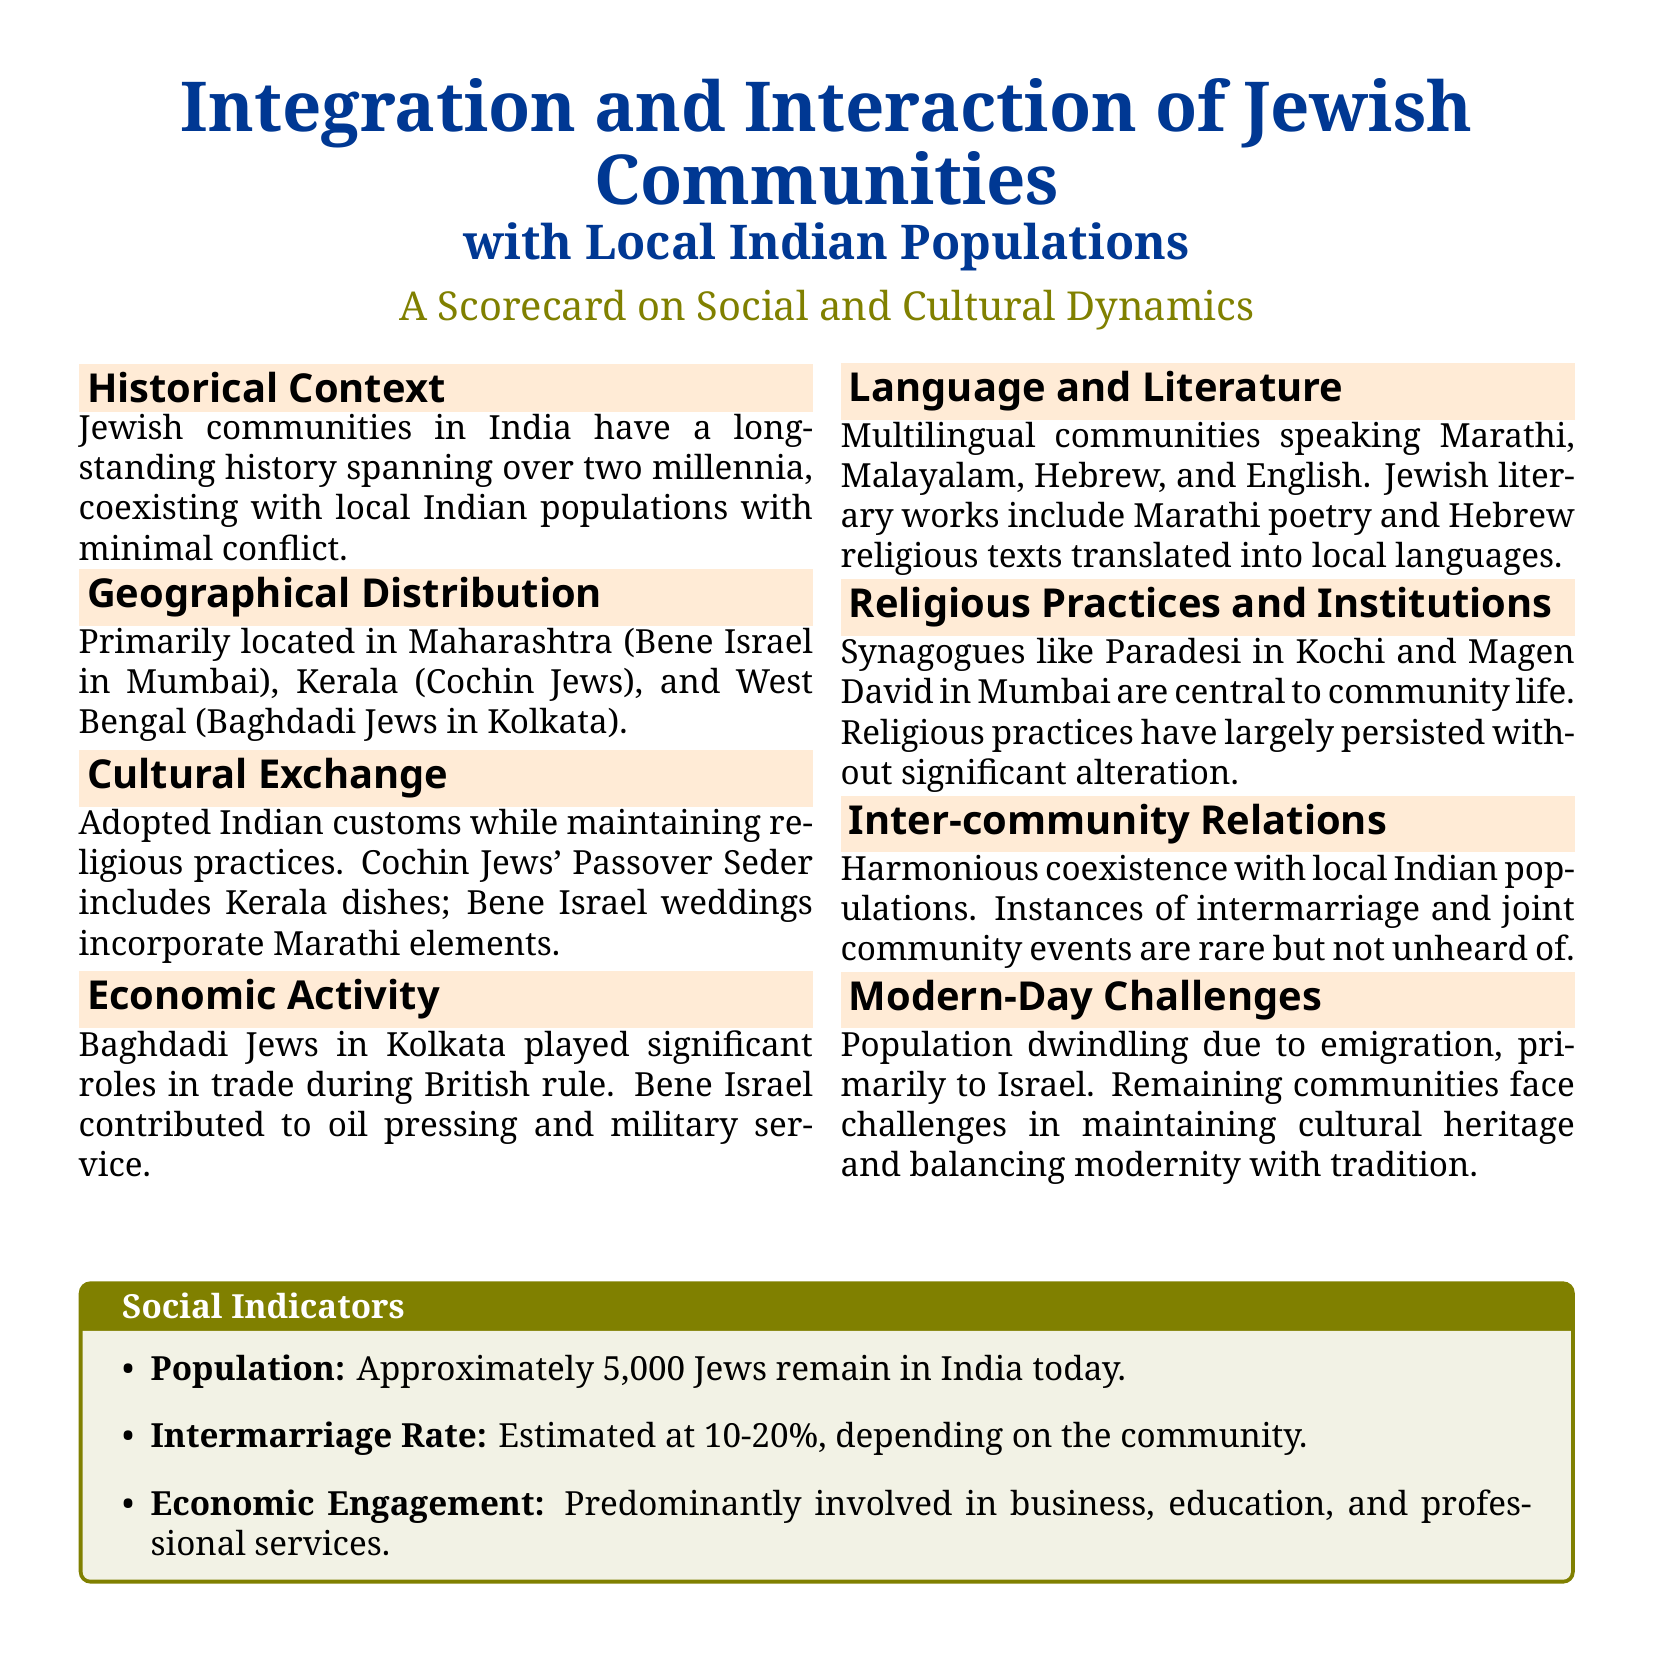What are the primary locations of Jewish communities in India? The document mentions Maharashtra, Kerala, and West Bengal as the primary locations of Jewish communities in India.
Answer: Maharashtra, Kerala, West Bengal How many Jews are estimated to remain in India today? The population statistic provided in the document states that approximately 5,000 Jews remain in India today.
Answer: Approximately 5,000 What is the intermarriage rate among Jewish communities in India? The document estimates the intermarriage rate to be between 10-20%, depending on the community.
Answer: 10-20% What role did Baghdadi Jews play during British rule in India? The document states that Baghdadi Jews in Kolkata played significant roles in trade during British rule.
Answer: Trade Which synagogue is mentioned in connection with Kochi? The document specifically mentions Paradesi synagogue as being central to the community life in Kochi.
Answer: Paradesi What language do Jewish communities in India predominantly speak? The document indicates that Multilingual communities speak Marathi, Malayalam, Hebrew, and English.
Answer: Marathi, Malayalam, Hebrew, English Why are modern-day challenges affecting Jewish communities in India? The document outlines emigration to Israel and challenges in maintaining cultural heritage as modern-day challenges.
Answer: Emigration, cultural heritage What significant cultural aspects do Cochin Jews incorporate into their Passover Seder? The document notes that Cochin Jews' Passover Seder includes Kerala dishes as a cultural aspect.
Answer: Kerala dishes What is a notable economic engagement of Jewish communities in India? The document states that Jewish communities are predominantly involved in business, education, and professional services.
Answer: Business, education, professional services 